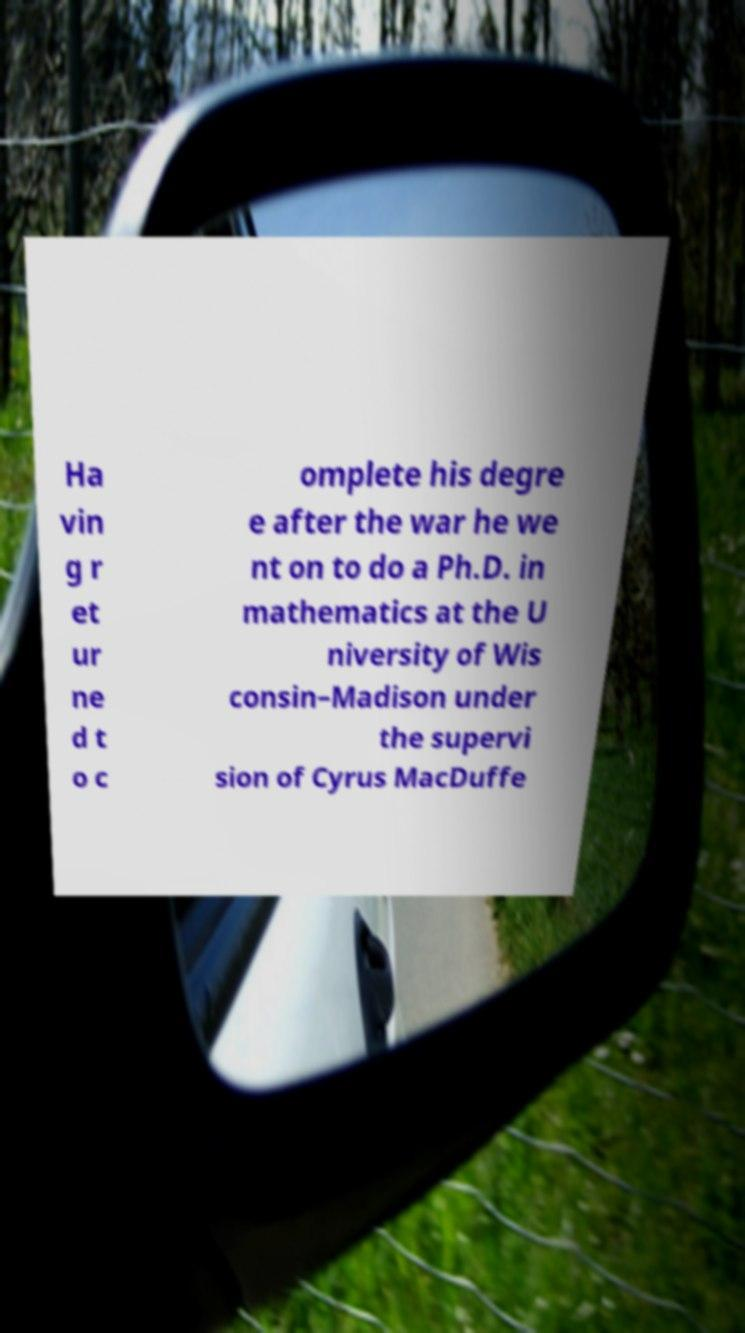There's text embedded in this image that I need extracted. Can you transcribe it verbatim? Ha vin g r et ur ne d t o c omplete his degre e after the war he we nt on to do a Ph.D. in mathematics at the U niversity of Wis consin–Madison under the supervi sion of Cyrus MacDuffe 